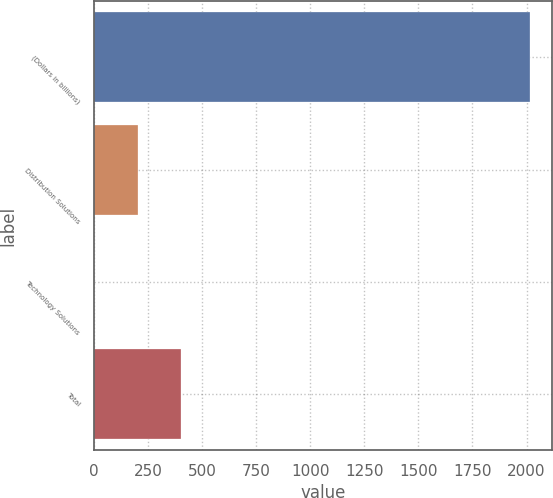<chart> <loc_0><loc_0><loc_500><loc_500><bar_chart><fcel>(Dollars in billions)<fcel>Distribution Solutions<fcel>Technology Solutions<fcel>Total<nl><fcel>2016<fcel>203.4<fcel>2<fcel>404.8<nl></chart> 